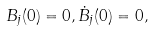Convert formula to latex. <formula><loc_0><loc_0><loc_500><loc_500>B _ { j } ( 0 ) = 0 , \dot { B } _ { j } ( 0 ) = 0 ,</formula> 